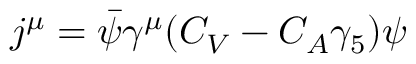<formula> <loc_0><loc_0><loc_500><loc_500>j ^ { \mu } = \bar { \psi } \gamma ^ { \mu } ( C _ { V } - C _ { A } \gamma _ { 5 } ) \psi</formula> 